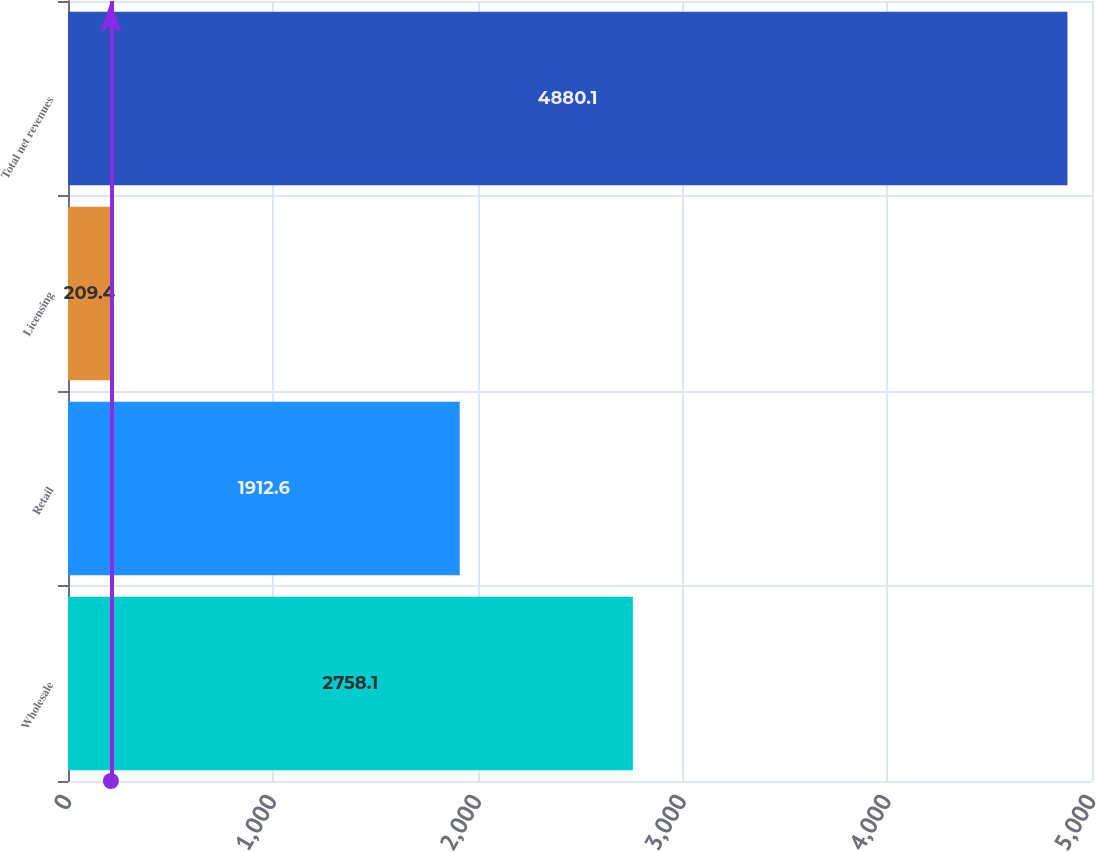Convert chart. <chart><loc_0><loc_0><loc_500><loc_500><bar_chart><fcel>Wholesale<fcel>Retail<fcel>Licensing<fcel>Total net revenues<nl><fcel>2758.1<fcel>1912.6<fcel>209.4<fcel>4880.1<nl></chart> 